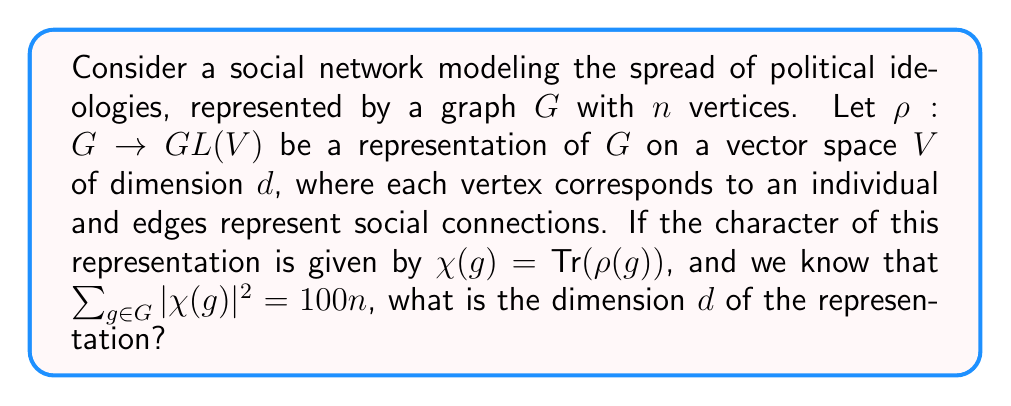Show me your answer to this math problem. Let's approach this step-by-step:

1) In representation theory, we have a fundamental result known as the orthogonality relations for characters. One form of this states that:

   $$\sum_{g \in G} |\chi(g)|^2 = |G| \cdot \dim(V)$$

   where $|G|$ is the order of the group (in this case, the number of vertices $n$), and $\dim(V)$ is the dimension of the representation (which we're trying to find).

2) We're given that $\sum_{g \in G} |\chi(g)|^2 = 100n$

3) Comparing this with the orthogonality relation, we can set up the equation:

   $$100n = n \cdot \dim(V)$$

4) Simplifying:

   $$100 = \dim(V)$$

Therefore, the dimension of the representation is 100.

This result suggests that in our model, each individual's ideological state is represented by a 100-dimensional vector, allowing for a complex interplay of various political beliefs and their spread through the social network.
Answer: $d = 100$ 